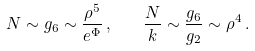<formula> <loc_0><loc_0><loc_500><loc_500>N \sim g _ { 6 } \sim \frac { \rho ^ { 5 } } { e ^ { \Phi } } \, , \quad \frac { N } { k } \sim \frac { g _ { 6 } } { g _ { 2 } } \sim \rho ^ { 4 } \, .</formula> 